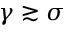<formula> <loc_0><loc_0><loc_500><loc_500>\gamma \gtrsim \sigma</formula> 